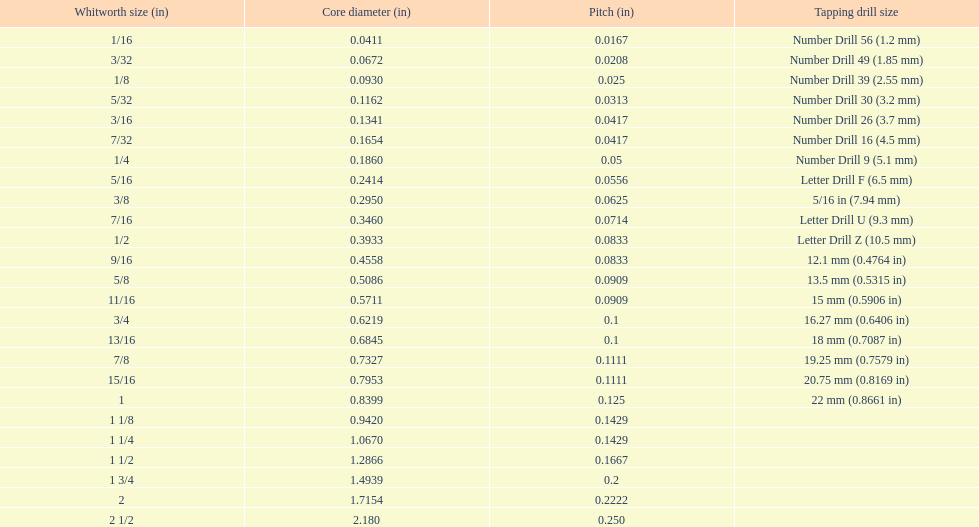Which whitworth size has the same number of threads per inch as 3/16? 7/32. 